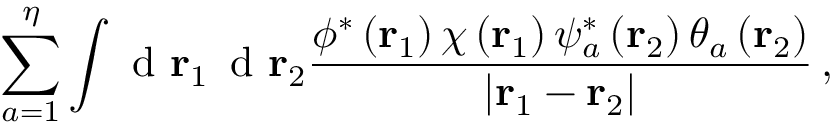Convert formula to latex. <formula><loc_0><loc_0><loc_500><loc_500>\sum _ { a = 1 } ^ { \eta } \int d \mathbf r _ { 1 } \, d \mathbf r _ { 2 } \frac { \phi ^ { * } \left ( \mathbf r _ { 1 } \right ) \chi \left ( \mathbf r _ { 1 } \right ) \psi _ { a } ^ { * } \left ( \mathbf r _ { 2 } \right ) \theta _ { a } \left ( \mathbf r _ { 2 } \right ) } { \left | \mathbf r _ { 1 } - \mathbf r _ { 2 } \right | } \, ,</formula> 